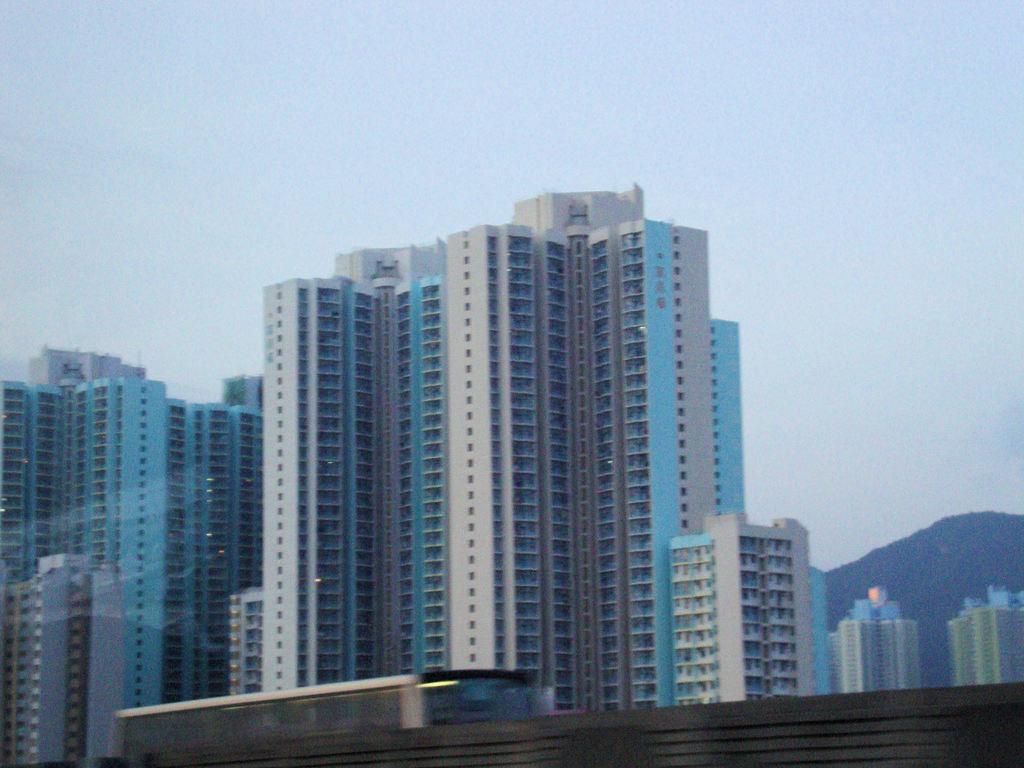Please provide a concise description of this image. In this image I can see few buildings, a bridge and a vehicle on the bridge. In the background I can see a mountain and the sky. 